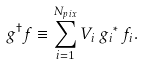Convert formula to latex. <formula><loc_0><loc_0><loc_500><loc_500>g ^ { \dagger } f \equiv \sum _ { i = 1 } ^ { N _ { p i x } } V _ { i } \, { g _ { i } } ^ { * } \, f _ { i } .</formula> 